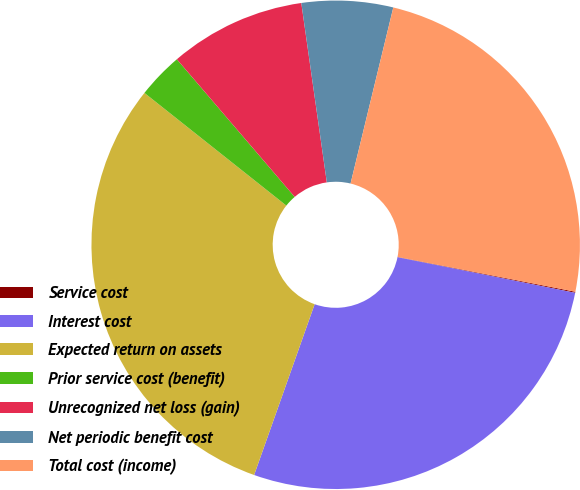<chart> <loc_0><loc_0><loc_500><loc_500><pie_chart><fcel>Service cost<fcel>Interest cost<fcel>Expected return on assets<fcel>Prior service cost (benefit)<fcel>Unrecognized net loss (gain)<fcel>Net periodic benefit cost<fcel>Total cost (income)<nl><fcel>0.07%<fcel>27.27%<fcel>30.26%<fcel>3.05%<fcel>9.02%<fcel>6.04%<fcel>24.29%<nl></chart> 